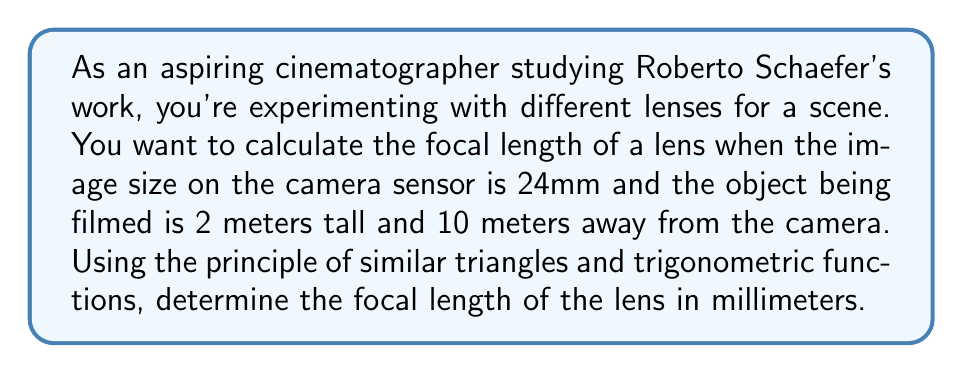Show me your answer to this math problem. To solve this problem, we'll use the principle of similar triangles and the tangent function. Let's break it down step-by-step:

1) First, let's define our variables:
   $f$ = focal length (unknown)
   $h$ = height of the object (2 meters = 2000mm)
   $d$ = distance to the object (10 meters = 10000mm)
   $i$ = image size on the sensor (24mm)

2) We can set up two similar triangles:
   - One triangle is formed by the object and the distance to the lens
   - The other is formed by the image on the sensor and the focal length

3) The ratio of these triangles can be expressed as:

   $$\frac{h}{d} = \frac{i}{f}$$

4) We can also express this using the tangent function:

   $$\tan \theta = \frac{h}{d} = \frac{i}{f}$$

5) Rearranging the equation to solve for $f$:

   $$f = \frac{i \cdot d}{h}$$

6) Now we can substitute our known values:

   $$f = \frac{24 \text{ mm} \cdot 10000 \text{ mm}}{2000 \text{ mm}}$$

7) Simplify:

   $$f = \frac{240000}{2000} = 120 \text{ mm}$$

[asy]
import geometry;

size(200);

pair A = (0,0);
pair B = (100,0);
pair C = (100,50);
pair D = (0,10);

draw(A--B--C--cycle);
draw(A--D);

label("Lens", A, SW);
label("Object", C, NE);
label("Image", D, NW);
label("$d$", (50,0), S);
label("$h$", (100,25), E);
label("$f$", (0,5), W);
label("$i$", (0,5), E);

[/asy]

This diagram illustrates the similar triangles formed by the object, lens, and image on the sensor.
Answer: The focal length of the lens is 120 mm. 